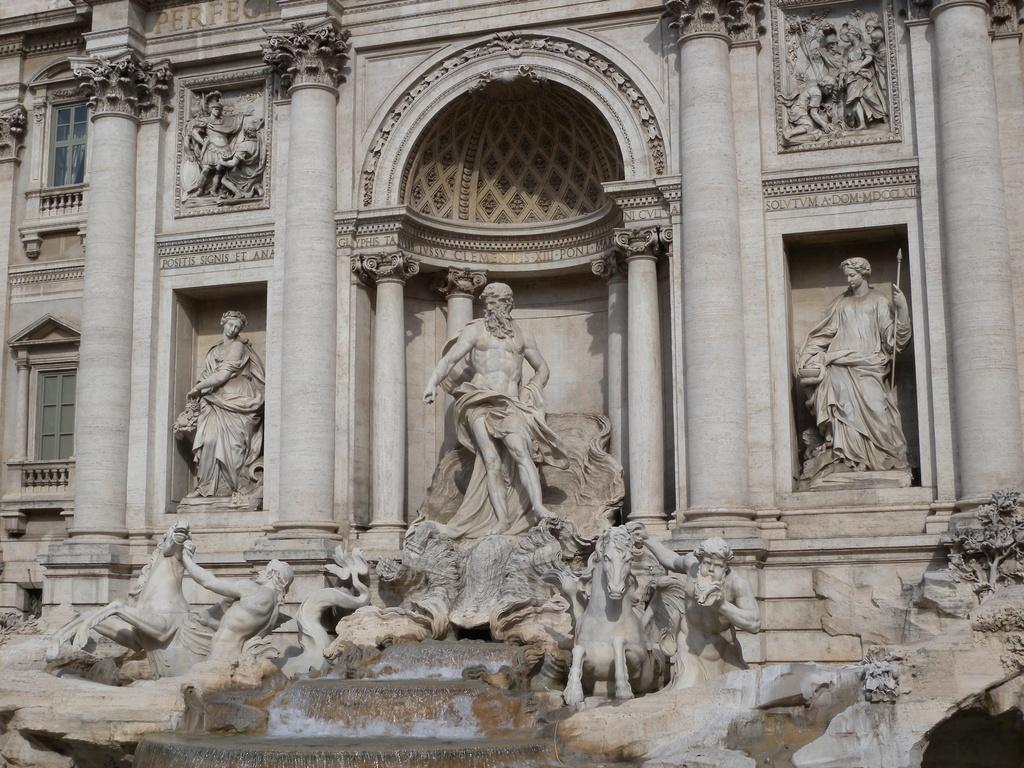Could you give a brief overview of what you see in this image? In this picture I see a building and I see number of sculptures. 